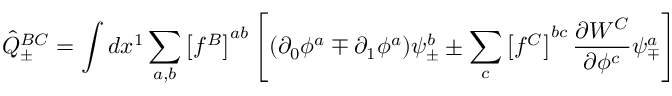<formula> <loc_0><loc_0><loc_500><loc_500>{ \hat { Q } } _ { \pm } ^ { B C } = \int d x ^ { 1 } \sum _ { a , b } \left [ f ^ { B } \right ] ^ { a b } \left [ ( \partial _ { 0 } \phi ^ { a } \mp \partial _ { 1 } \phi ^ { a } ) \psi _ { \pm } ^ { b } \pm \sum _ { c } \left [ f ^ { C } \right ] ^ { b c } \frac { \partial W ^ { C } } { \partial \phi ^ { c } } \psi _ { \mp } ^ { a } \right ]</formula> 